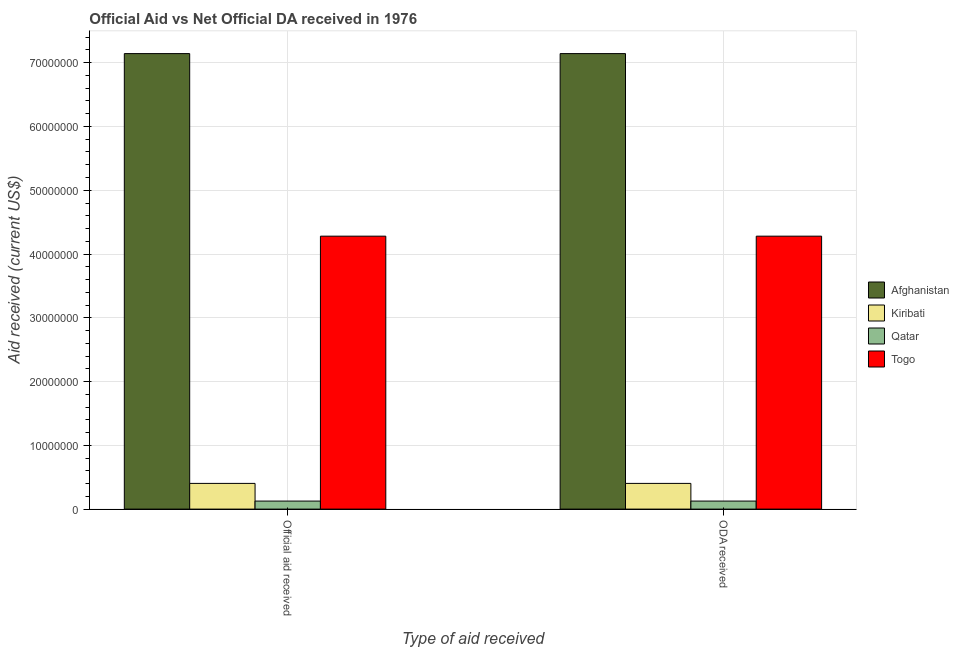How many different coloured bars are there?
Give a very brief answer. 4. Are the number of bars on each tick of the X-axis equal?
Provide a succinct answer. Yes. How many bars are there on the 2nd tick from the left?
Your answer should be very brief. 4. How many bars are there on the 1st tick from the right?
Your response must be concise. 4. What is the label of the 2nd group of bars from the left?
Keep it short and to the point. ODA received. What is the official aid received in Togo?
Provide a succinct answer. 4.28e+07. Across all countries, what is the maximum official aid received?
Your response must be concise. 7.14e+07. Across all countries, what is the minimum official aid received?
Provide a succinct answer. 1.26e+06. In which country was the oda received maximum?
Provide a succinct answer. Afghanistan. In which country was the oda received minimum?
Ensure brevity in your answer.  Qatar. What is the total oda received in the graph?
Provide a short and direct response. 1.20e+08. What is the difference between the official aid received in Afghanistan and that in Qatar?
Your answer should be compact. 7.02e+07. What is the difference between the oda received in Afghanistan and the official aid received in Togo?
Provide a succinct answer. 2.86e+07. What is the average official aid received per country?
Your answer should be compact. 2.99e+07. What is the ratio of the oda received in Qatar to that in Togo?
Keep it short and to the point. 0.03. What does the 4th bar from the left in Official aid received represents?
Your answer should be compact. Togo. What does the 3rd bar from the right in ODA received represents?
Your answer should be very brief. Kiribati. How many bars are there?
Make the answer very short. 8. Are all the bars in the graph horizontal?
Your answer should be very brief. No. What is the difference between two consecutive major ticks on the Y-axis?
Your response must be concise. 1.00e+07. Are the values on the major ticks of Y-axis written in scientific E-notation?
Provide a succinct answer. No. Does the graph contain any zero values?
Offer a terse response. No. Does the graph contain grids?
Your answer should be compact. Yes. Where does the legend appear in the graph?
Keep it short and to the point. Center right. How many legend labels are there?
Offer a terse response. 4. How are the legend labels stacked?
Provide a succinct answer. Vertical. What is the title of the graph?
Make the answer very short. Official Aid vs Net Official DA received in 1976 . Does "Slovenia" appear as one of the legend labels in the graph?
Keep it short and to the point. No. What is the label or title of the X-axis?
Offer a terse response. Type of aid received. What is the label or title of the Y-axis?
Give a very brief answer. Aid received (current US$). What is the Aid received (current US$) in Afghanistan in Official aid received?
Keep it short and to the point. 7.14e+07. What is the Aid received (current US$) in Kiribati in Official aid received?
Make the answer very short. 4.03e+06. What is the Aid received (current US$) in Qatar in Official aid received?
Your answer should be compact. 1.26e+06. What is the Aid received (current US$) in Togo in Official aid received?
Offer a terse response. 4.28e+07. What is the Aid received (current US$) of Afghanistan in ODA received?
Your answer should be very brief. 7.14e+07. What is the Aid received (current US$) of Kiribati in ODA received?
Offer a very short reply. 4.03e+06. What is the Aid received (current US$) in Qatar in ODA received?
Provide a short and direct response. 1.26e+06. What is the Aid received (current US$) in Togo in ODA received?
Provide a short and direct response. 4.28e+07. Across all Type of aid received, what is the maximum Aid received (current US$) in Afghanistan?
Offer a very short reply. 7.14e+07. Across all Type of aid received, what is the maximum Aid received (current US$) in Kiribati?
Keep it short and to the point. 4.03e+06. Across all Type of aid received, what is the maximum Aid received (current US$) of Qatar?
Your answer should be very brief. 1.26e+06. Across all Type of aid received, what is the maximum Aid received (current US$) of Togo?
Keep it short and to the point. 4.28e+07. Across all Type of aid received, what is the minimum Aid received (current US$) of Afghanistan?
Your answer should be compact. 7.14e+07. Across all Type of aid received, what is the minimum Aid received (current US$) in Kiribati?
Your answer should be compact. 4.03e+06. Across all Type of aid received, what is the minimum Aid received (current US$) of Qatar?
Keep it short and to the point. 1.26e+06. Across all Type of aid received, what is the minimum Aid received (current US$) of Togo?
Provide a short and direct response. 4.28e+07. What is the total Aid received (current US$) in Afghanistan in the graph?
Your answer should be very brief. 1.43e+08. What is the total Aid received (current US$) of Kiribati in the graph?
Offer a very short reply. 8.06e+06. What is the total Aid received (current US$) of Qatar in the graph?
Your answer should be very brief. 2.52e+06. What is the total Aid received (current US$) of Togo in the graph?
Give a very brief answer. 8.56e+07. What is the difference between the Aid received (current US$) of Afghanistan in Official aid received and that in ODA received?
Your answer should be very brief. 0. What is the difference between the Aid received (current US$) of Qatar in Official aid received and that in ODA received?
Offer a very short reply. 0. What is the difference between the Aid received (current US$) in Togo in Official aid received and that in ODA received?
Keep it short and to the point. 0. What is the difference between the Aid received (current US$) of Afghanistan in Official aid received and the Aid received (current US$) of Kiribati in ODA received?
Make the answer very short. 6.74e+07. What is the difference between the Aid received (current US$) in Afghanistan in Official aid received and the Aid received (current US$) in Qatar in ODA received?
Provide a short and direct response. 7.02e+07. What is the difference between the Aid received (current US$) of Afghanistan in Official aid received and the Aid received (current US$) of Togo in ODA received?
Provide a short and direct response. 2.86e+07. What is the difference between the Aid received (current US$) of Kiribati in Official aid received and the Aid received (current US$) of Qatar in ODA received?
Offer a terse response. 2.77e+06. What is the difference between the Aid received (current US$) in Kiribati in Official aid received and the Aid received (current US$) in Togo in ODA received?
Provide a succinct answer. -3.88e+07. What is the difference between the Aid received (current US$) of Qatar in Official aid received and the Aid received (current US$) of Togo in ODA received?
Keep it short and to the point. -4.15e+07. What is the average Aid received (current US$) of Afghanistan per Type of aid received?
Offer a terse response. 7.14e+07. What is the average Aid received (current US$) of Kiribati per Type of aid received?
Provide a succinct answer. 4.03e+06. What is the average Aid received (current US$) of Qatar per Type of aid received?
Make the answer very short. 1.26e+06. What is the average Aid received (current US$) in Togo per Type of aid received?
Ensure brevity in your answer.  4.28e+07. What is the difference between the Aid received (current US$) in Afghanistan and Aid received (current US$) in Kiribati in Official aid received?
Your response must be concise. 6.74e+07. What is the difference between the Aid received (current US$) in Afghanistan and Aid received (current US$) in Qatar in Official aid received?
Ensure brevity in your answer.  7.02e+07. What is the difference between the Aid received (current US$) in Afghanistan and Aid received (current US$) in Togo in Official aid received?
Keep it short and to the point. 2.86e+07. What is the difference between the Aid received (current US$) in Kiribati and Aid received (current US$) in Qatar in Official aid received?
Offer a very short reply. 2.77e+06. What is the difference between the Aid received (current US$) of Kiribati and Aid received (current US$) of Togo in Official aid received?
Make the answer very short. -3.88e+07. What is the difference between the Aid received (current US$) in Qatar and Aid received (current US$) in Togo in Official aid received?
Give a very brief answer. -4.15e+07. What is the difference between the Aid received (current US$) of Afghanistan and Aid received (current US$) of Kiribati in ODA received?
Your answer should be very brief. 6.74e+07. What is the difference between the Aid received (current US$) in Afghanistan and Aid received (current US$) in Qatar in ODA received?
Ensure brevity in your answer.  7.02e+07. What is the difference between the Aid received (current US$) of Afghanistan and Aid received (current US$) of Togo in ODA received?
Keep it short and to the point. 2.86e+07. What is the difference between the Aid received (current US$) of Kiribati and Aid received (current US$) of Qatar in ODA received?
Offer a very short reply. 2.77e+06. What is the difference between the Aid received (current US$) in Kiribati and Aid received (current US$) in Togo in ODA received?
Your answer should be very brief. -3.88e+07. What is the difference between the Aid received (current US$) in Qatar and Aid received (current US$) in Togo in ODA received?
Ensure brevity in your answer.  -4.15e+07. What is the ratio of the Aid received (current US$) of Afghanistan in Official aid received to that in ODA received?
Offer a very short reply. 1. What is the ratio of the Aid received (current US$) in Qatar in Official aid received to that in ODA received?
Provide a succinct answer. 1. What is the difference between the highest and the second highest Aid received (current US$) of Qatar?
Give a very brief answer. 0. What is the difference between the highest and the second highest Aid received (current US$) of Togo?
Provide a short and direct response. 0. What is the difference between the highest and the lowest Aid received (current US$) of Afghanistan?
Your answer should be very brief. 0. What is the difference between the highest and the lowest Aid received (current US$) of Kiribati?
Provide a succinct answer. 0. What is the difference between the highest and the lowest Aid received (current US$) in Togo?
Provide a succinct answer. 0. 